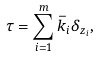<formula> <loc_0><loc_0><loc_500><loc_500>\tau = \sum _ { i = 1 } ^ { m } \bar { k } _ { i } \delta _ { z _ { i } } ,</formula> 